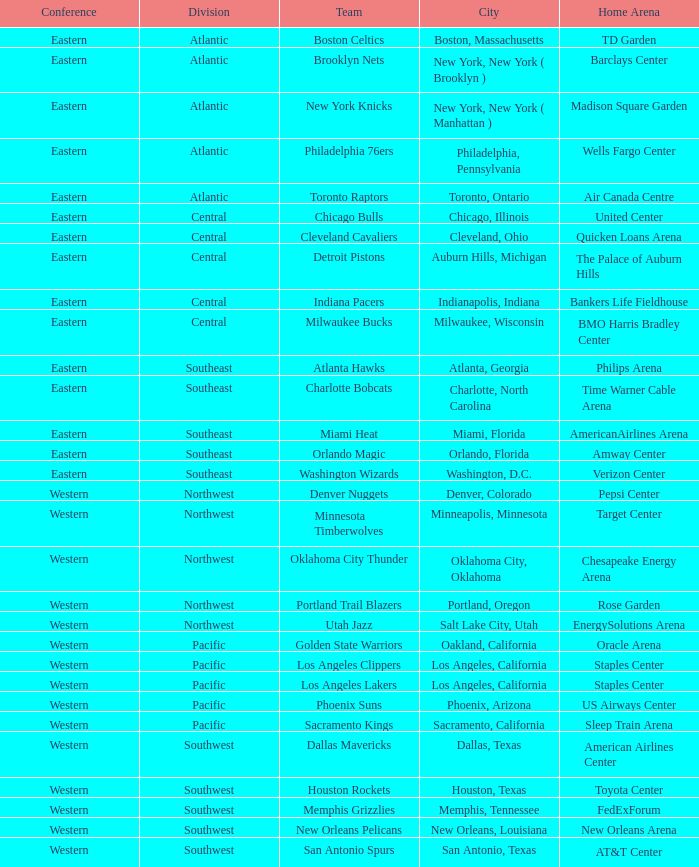Which city includes the Target Center arena? Minneapolis, Minnesota. 